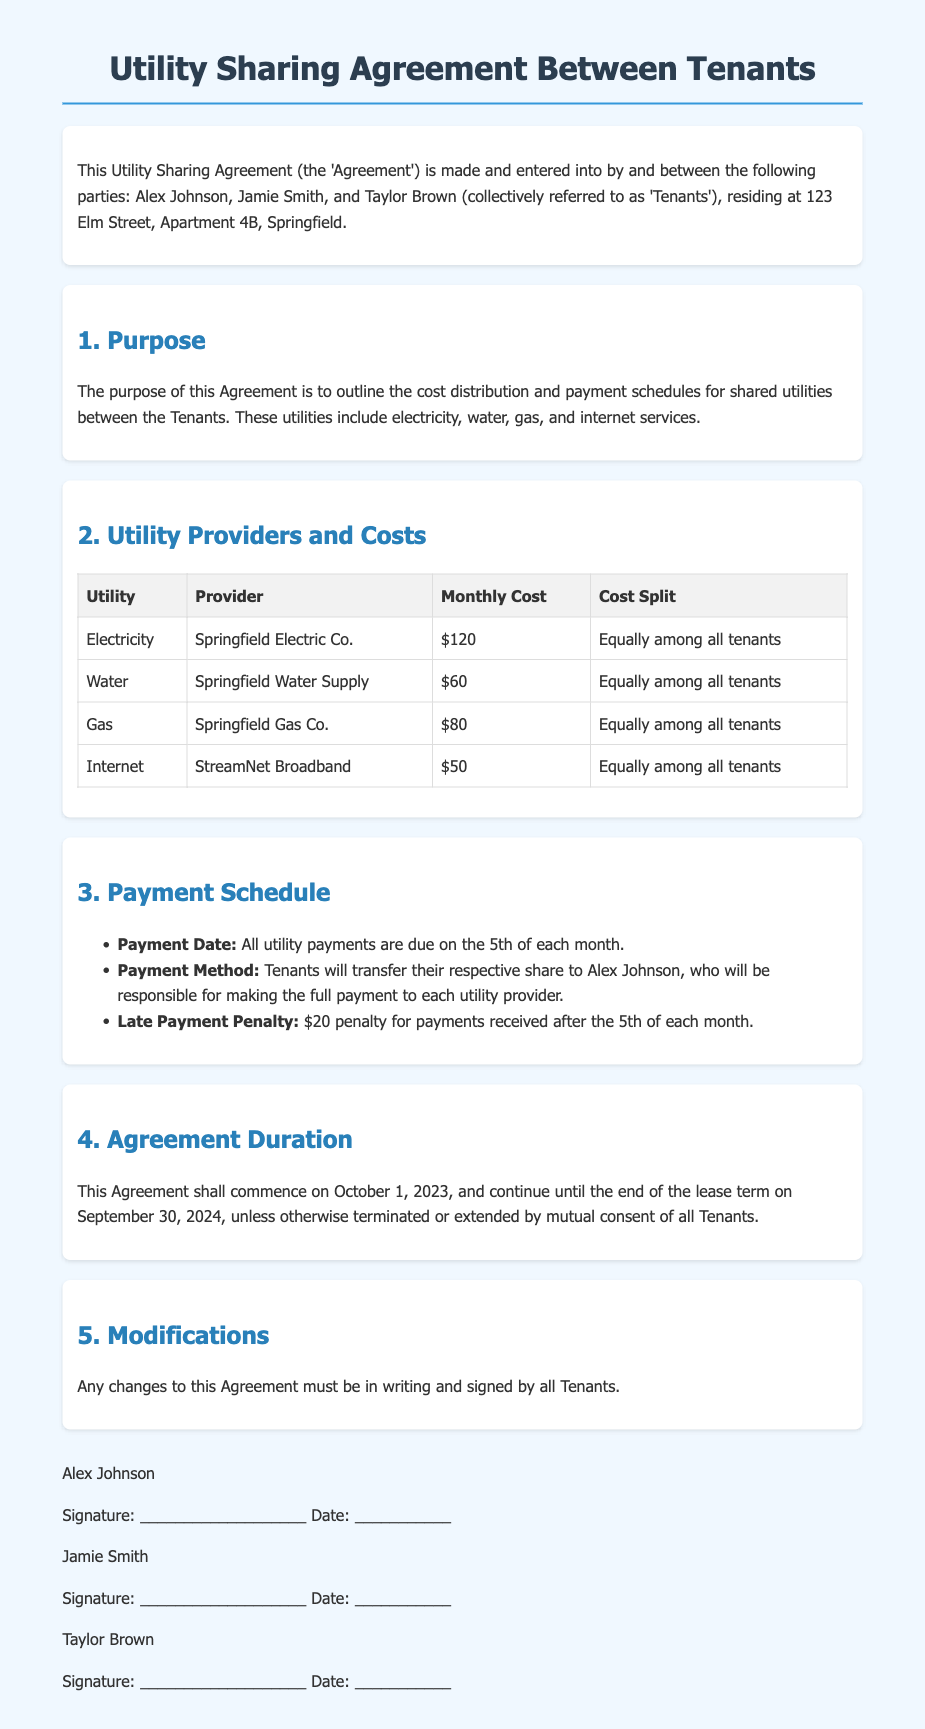What is the address of the Tenants? The address of the Tenants is stated in the introduction of the document, which is 123 Elm Street, Apartment 4B, Springfield.
Answer: 123 Elm Street, Apartment 4B, Springfield Who is responsible for making the full payment to utility providers? The document specifies that Alex Johnson will be responsible for making the full payment to each utility provider.
Answer: Alex Johnson What is the due date for utility payments? The payment schedule section outlines that all utility payments are due on the 5th of each month.
Answer: 5th of each month What is the late payment penalty amount? According to the document, the late payment penalty is stated as $20 for payments received after the 5th.
Answer: $20 How often is the cost of internet? The cost details in the utility table indicate the monthly cost for internet services.
Answer: Monthly How long does the Agreement last? The document mentions that the Agreement commences on October 1, 2023, and continues until September 30, 2024.
Answer: Until September 30, 2024 What is the total monthly cost of water? The table in the document specifies the monthly cost of water services.
Answer: $60 What type of changes require written consent? The modifications section states that any changes to the Agreement must be in writing and signed by all Tenants.
Answer: Changes to the Agreement 